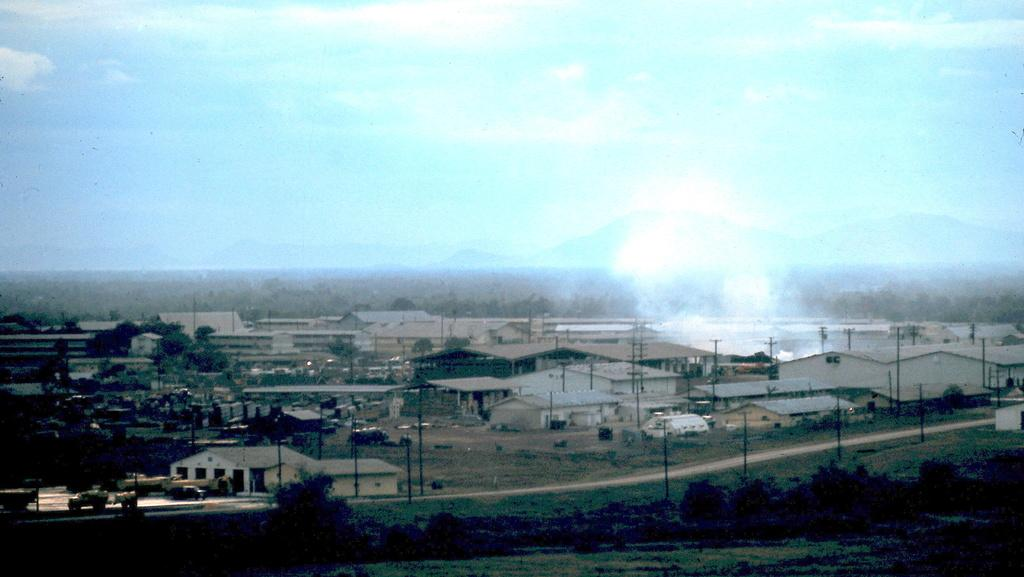What can be seen on the road in the image? There are vehicles on the road in the image. What type of structures are visible in the image? There are buildings visible in the image. What type of vegetation is present in the image? Trees are present in the image. What else can be seen in the image besides the vehicles and buildings? Poles and grass are visible in the image. What is visible in the background of the image? The sky is visible in the background of the image. What type of furniture can be seen in the image? There is no furniture present in the image; it features vehicles, buildings, trees, poles, grass, and the sky. How many men are visible in the image? There are no men present in the image. 